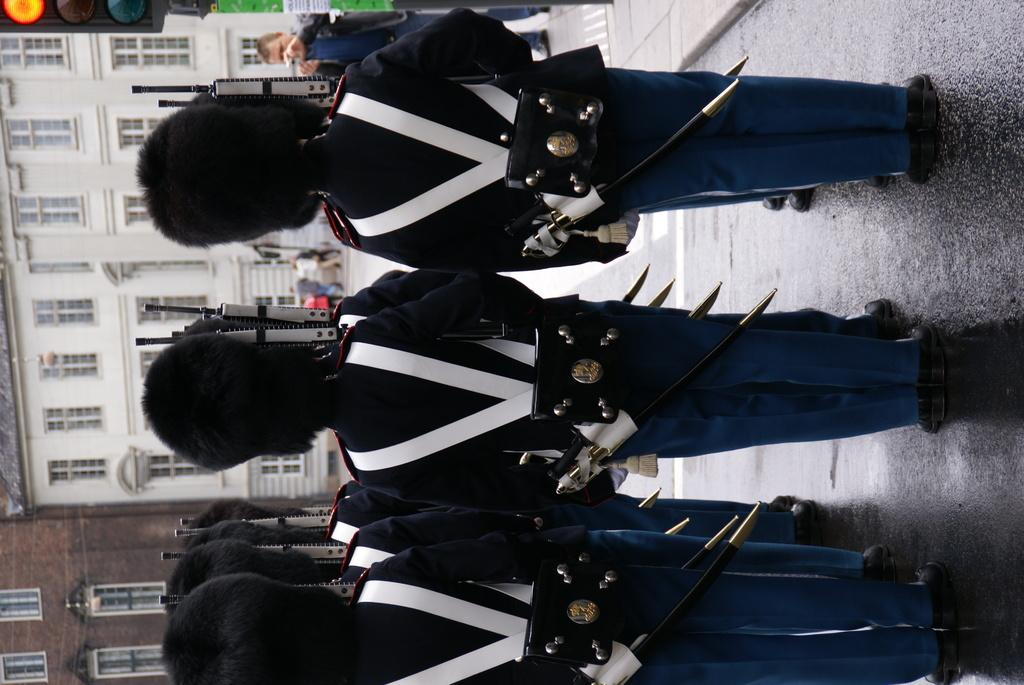What type of structure can be seen in the image? There is a building in the image. What helps regulate traffic in the image? There are traffic lights in the image. What type of visual content is present in the image? Cartoons are present in the image. How many stones are used as decoration in the image? There is no mention of stones in the image, so it is impossible to determine the number of stones present. 